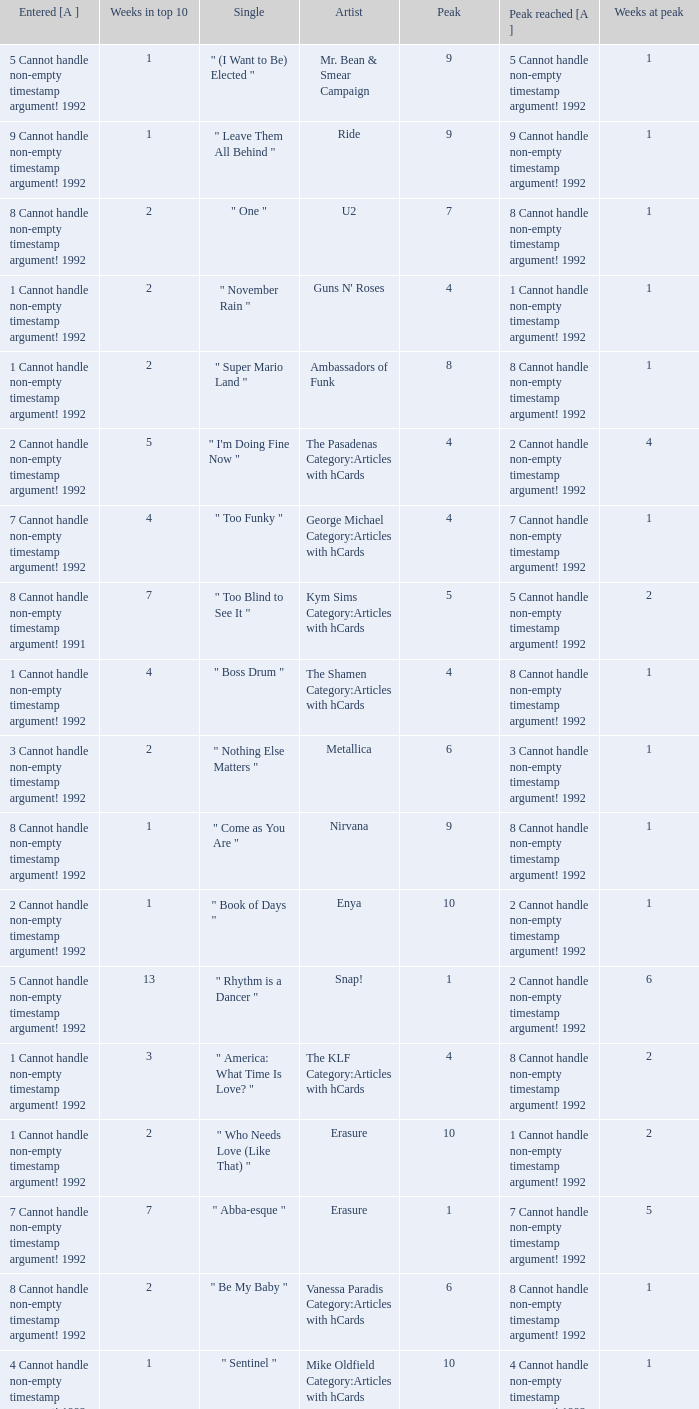What was the peak reached for a single with 4 weeks in the top 10 and entered in 7 cannot handle non-empty timestamp argument! 1992? 7 Cannot handle non-empty timestamp argument! 1992. 